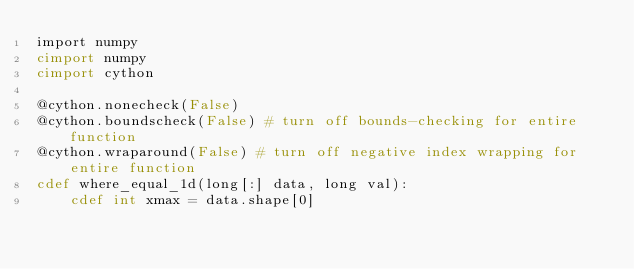Convert code to text. <code><loc_0><loc_0><loc_500><loc_500><_Cython_>import numpy
cimport numpy
cimport cython

@cython.nonecheck(False)
@cython.boundscheck(False) # turn off bounds-checking for entire function
@cython.wraparound(False) # turn off negative index wrapping for entire function
cdef where_equal_1d(long[:] data, long val):
    cdef int xmax = data.shape[0]</code> 